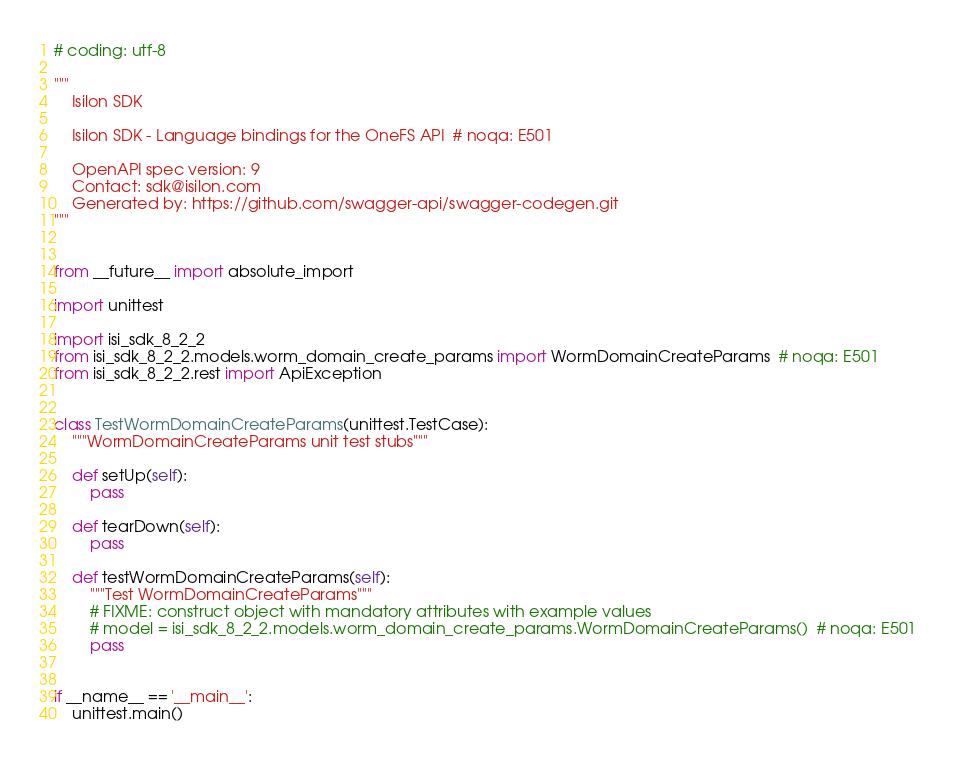Convert code to text. <code><loc_0><loc_0><loc_500><loc_500><_Python_># coding: utf-8

"""
    Isilon SDK

    Isilon SDK - Language bindings for the OneFS API  # noqa: E501

    OpenAPI spec version: 9
    Contact: sdk@isilon.com
    Generated by: https://github.com/swagger-api/swagger-codegen.git
"""


from __future__ import absolute_import

import unittest

import isi_sdk_8_2_2
from isi_sdk_8_2_2.models.worm_domain_create_params import WormDomainCreateParams  # noqa: E501
from isi_sdk_8_2_2.rest import ApiException


class TestWormDomainCreateParams(unittest.TestCase):
    """WormDomainCreateParams unit test stubs"""

    def setUp(self):
        pass

    def tearDown(self):
        pass

    def testWormDomainCreateParams(self):
        """Test WormDomainCreateParams"""
        # FIXME: construct object with mandatory attributes with example values
        # model = isi_sdk_8_2_2.models.worm_domain_create_params.WormDomainCreateParams()  # noqa: E501
        pass


if __name__ == '__main__':
    unittest.main()
</code> 